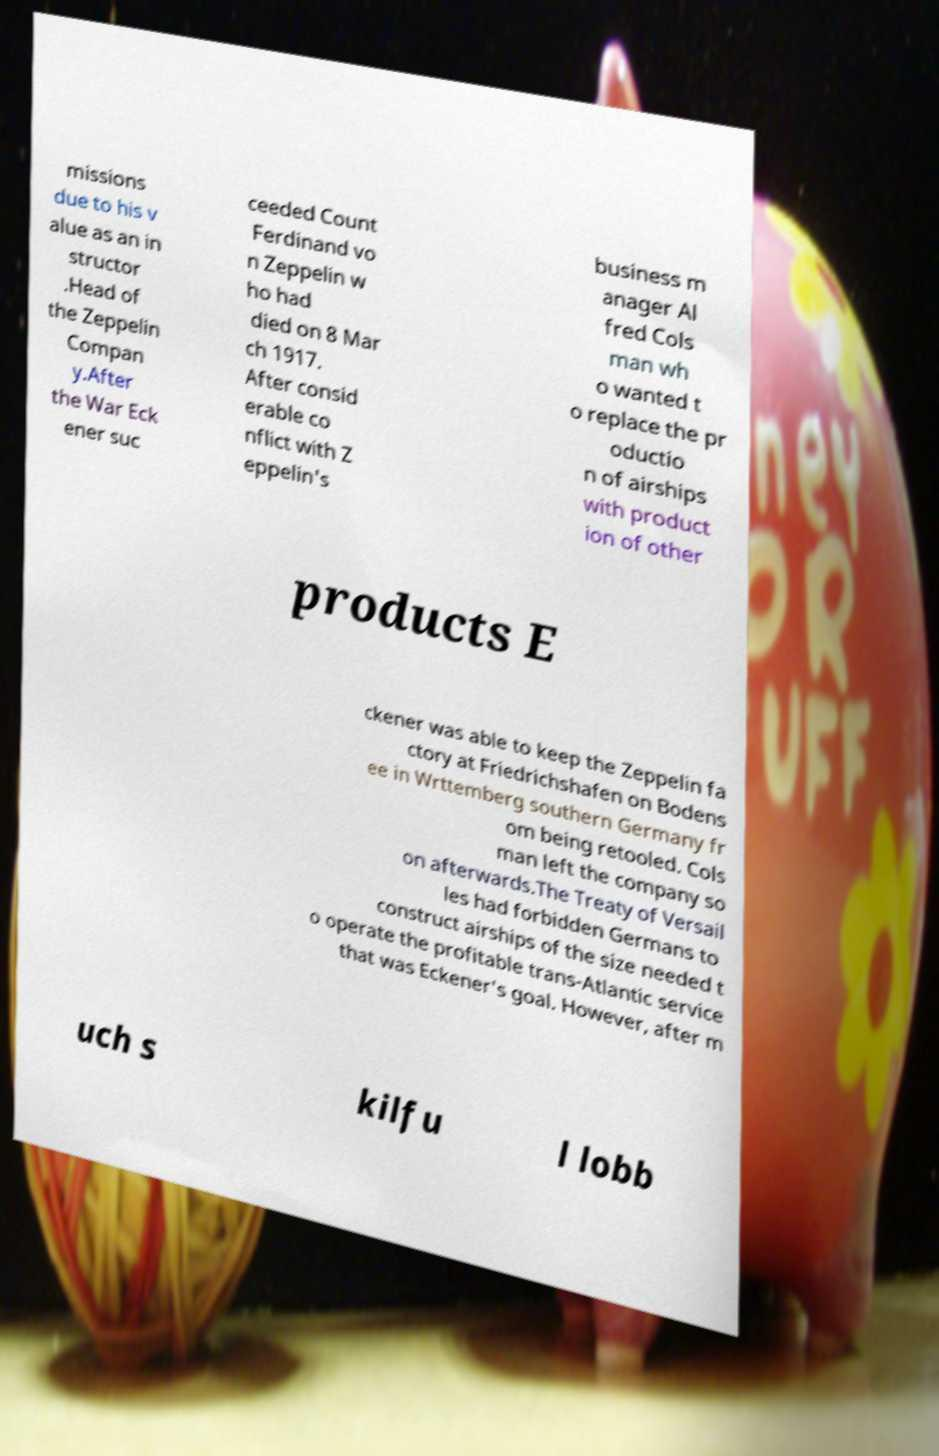Can you read and provide the text displayed in the image?This photo seems to have some interesting text. Can you extract and type it out for me? missions due to his v alue as an in structor .Head of the Zeppelin Compan y.After the War Eck ener suc ceeded Count Ferdinand vo n Zeppelin w ho had died on 8 Mar ch 1917. After consid erable co nflict with Z eppelin's business m anager Al fred Cols man wh o wanted t o replace the pr oductio n of airships with product ion of other products E ckener was able to keep the Zeppelin fa ctory at Friedrichshafen on Bodens ee in Wrttemberg southern Germany fr om being retooled. Cols man left the company so on afterwards.The Treaty of Versail les had forbidden Germans to construct airships of the size needed t o operate the profitable trans-Atlantic service that was Eckener's goal. However, after m uch s kilfu l lobb 